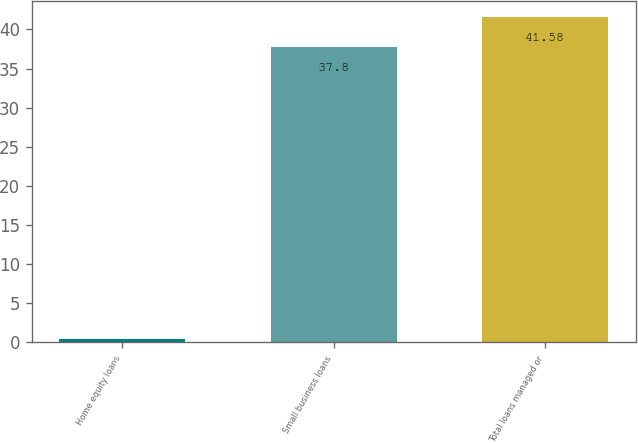Convert chart. <chart><loc_0><loc_0><loc_500><loc_500><bar_chart><fcel>Home equity loans<fcel>Small business loans<fcel>Total loans managed or<nl><fcel>0.4<fcel>37.8<fcel>41.58<nl></chart> 